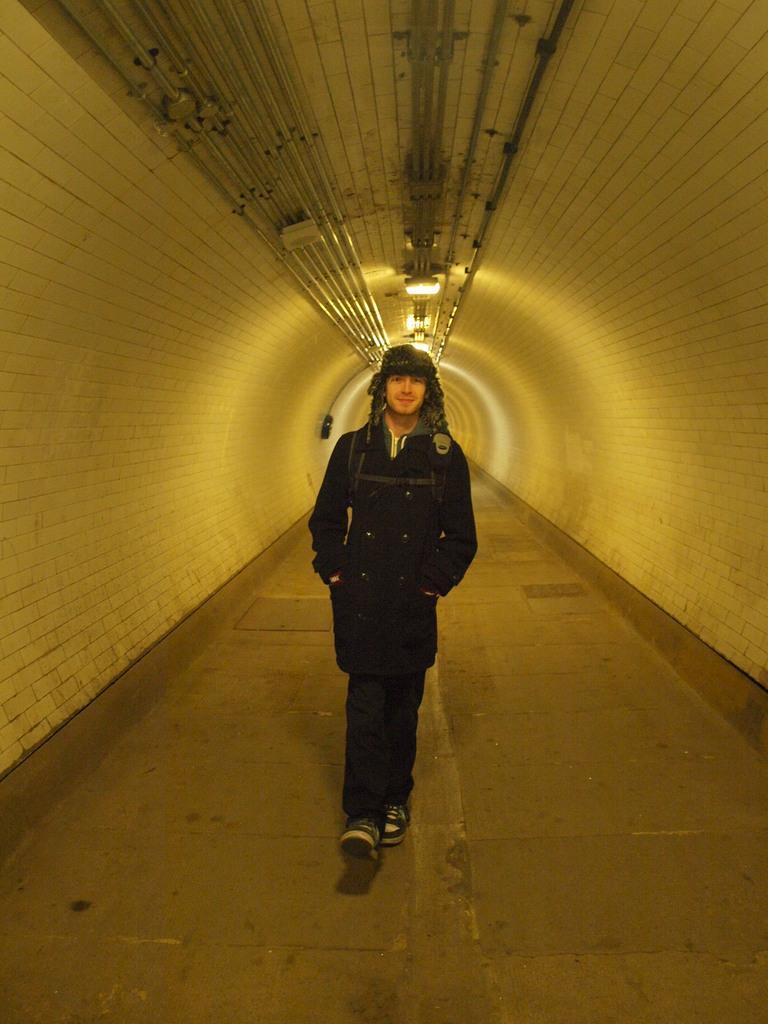Describe this image in one or two sentences. In this image there is a person walking on the road beside him there are walls. 